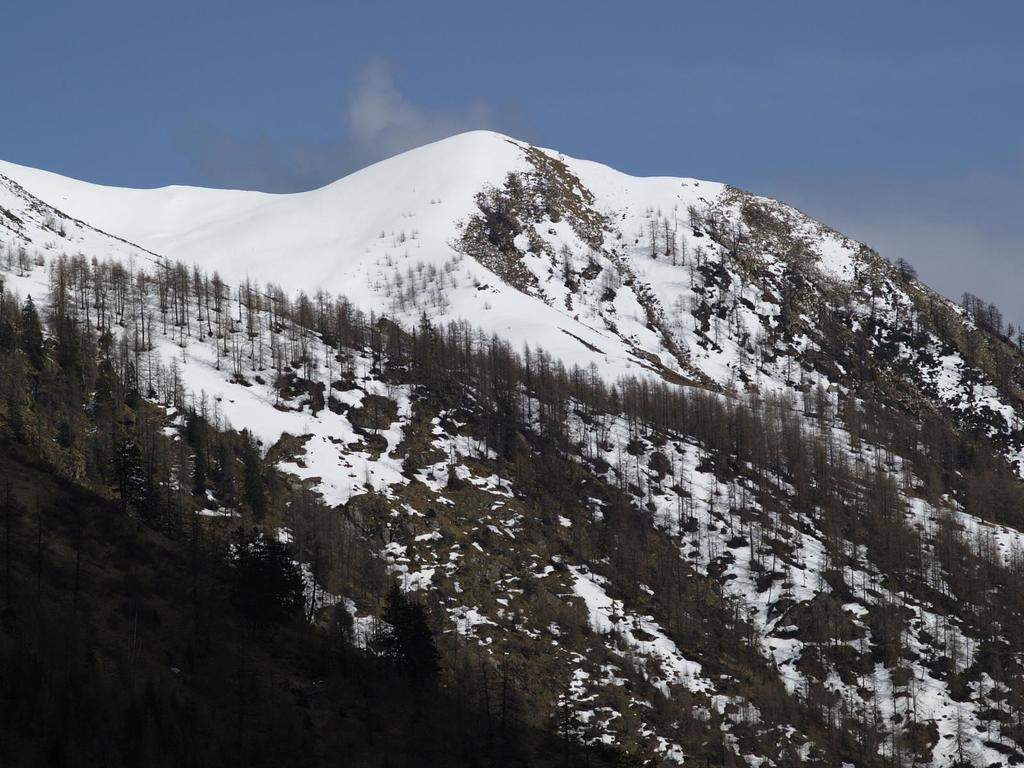What type of environment is depicted in the image? The image is an outside view. What natural elements can be seen in the image? There are trees and rocks in the image. What is the weather like in the image? There is snow on a hill in the image, indicating a cold or snowy environment. What is visible in the background of the image? The sky is visible in the image. What is the color of the sky in the image? The color of the sky is blue. What type of game is being played in the image? There is no game being played in the image; it is a view of an outdoor environment with trees, rocks, snow, and a blue sky. What type of space object can be seen in the image? There are no space objects present in the image; it is a view of an outdoor environment on Earth. 